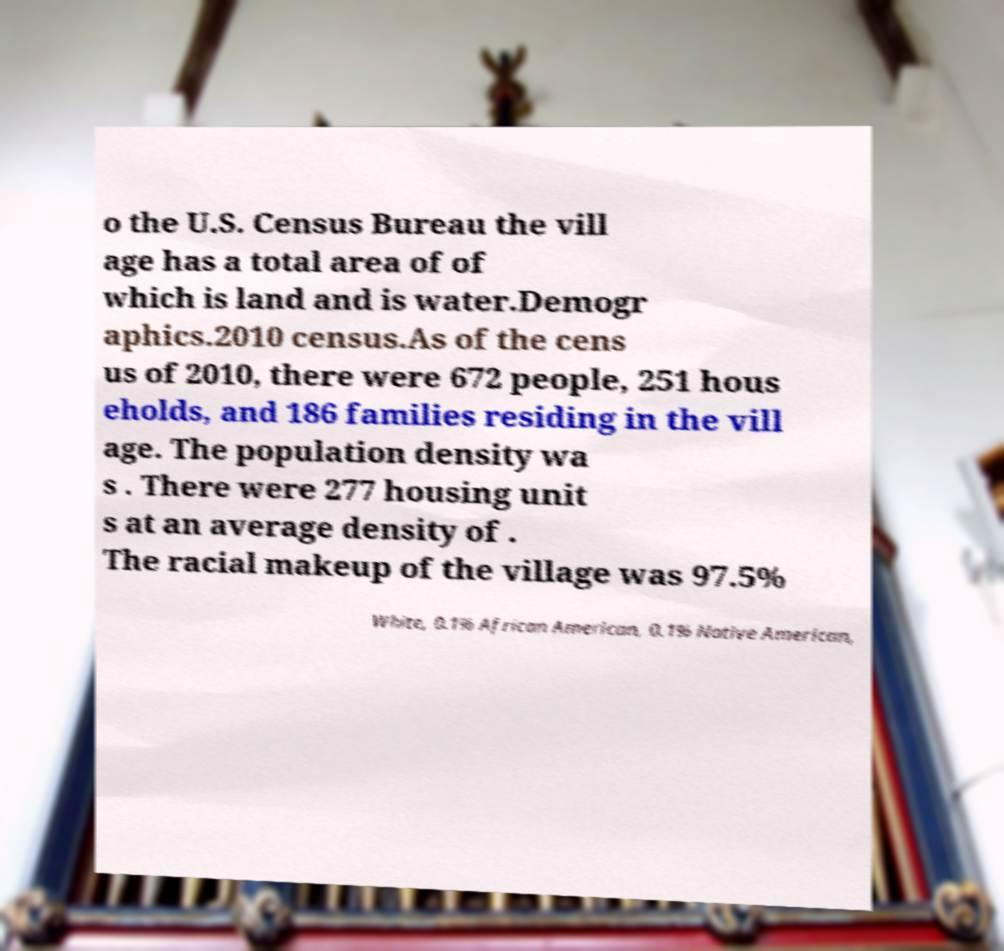Can you accurately transcribe the text from the provided image for me? o the U.S. Census Bureau the vill age has a total area of of which is land and is water.Demogr aphics.2010 census.As of the cens us of 2010, there were 672 people, 251 hous eholds, and 186 families residing in the vill age. The population density wa s . There were 277 housing unit s at an average density of . The racial makeup of the village was 97.5% White, 0.1% African American, 0.1% Native American, 